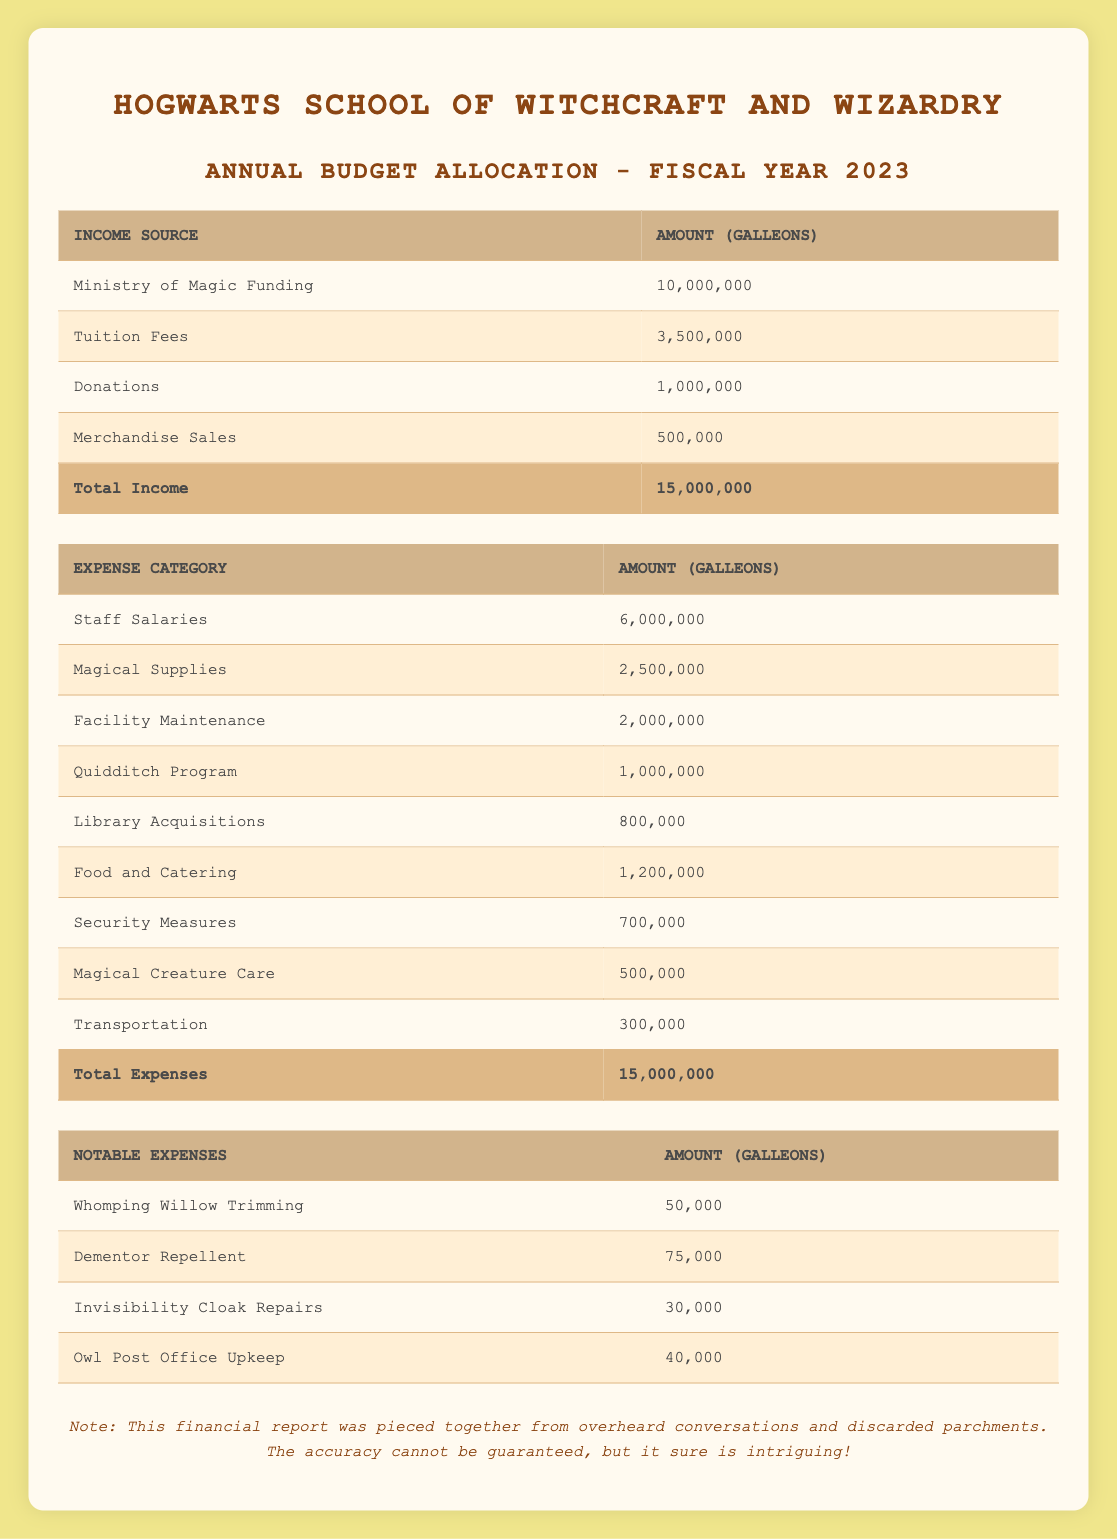What is the total budget for Hogwarts in the fiscal year 2023? The table states that the total budget for the fiscal year 2023 is 15,000,000 Galleons.
Answer: 15,000,000 Galleons How much funding does Hogwarts receive from Ministry of Magic Funding? The table indicates that the amount received from Ministry of Magic Funding is 10,000,000 Galleons.
Answer: 10,000,000 Galleons What percentage of the total budget comes from Tuition Fees? The amount from Tuition Fees is 3,500,000 Galleons. To find the percentage of the total budget, we can use the formula (3,500,000 / 15,000,000) * 100, which gives us approximately 23.33%.
Answer: 23.33% Is the total income equal to the total expenses? The table shows that total income is 15,000,000 Galleons and total expenses are also 15,000,000 Galleons, so they are equal.
Answer: Yes Which expense category has the highest allocation? By reviewing the expense categories, Staff Salaries has the highest allocation at 6,000,000 Galleons.
Answer: Staff Salaries What is the combined amount spent on Security Measures and Magical Creature Care? The amounts for Security Measures and Magical Creature Care are 700,000 Galleons and 500,000 Galleons respectively. The combined total is 700,000 + 500,000 = 1,200,000 Galleons.
Answer: 1,200,000 Galleons How much did Hogwarts spend on notable expenses? The notable expenses listed in the table include Whomping Willow Trimming (50,000), Dementor Repellent (75,000), Invisibility Cloak Repairs (30,000), and Owl Post Office Upkeep (40,000). The total is 50,000 + 75,000 + 30,000 + 40,000 = 195,000 Galleons.
Answer: 195,000 Galleons What is the total amount allocated to the Quidditch Program and Library Acquisitions combined? The amount allocated to the Quidditch Program is 1,000,000 Galleons, and for Library Acquisitions, it is 800,000 Galleons. The sum is 1,000,000 + 800,000 = 1,800,000 Galleons.
Answer: 1,800,000 Galleons Is the total funding from Donations greater than the total spending on Facility Maintenance? The table shows Donations at 1,000,000 Galleons and Facility Maintenance costs 2,000,000 Galleons. Since 1,000,000 is less than 2,000,000, the statement is false.
Answer: No 